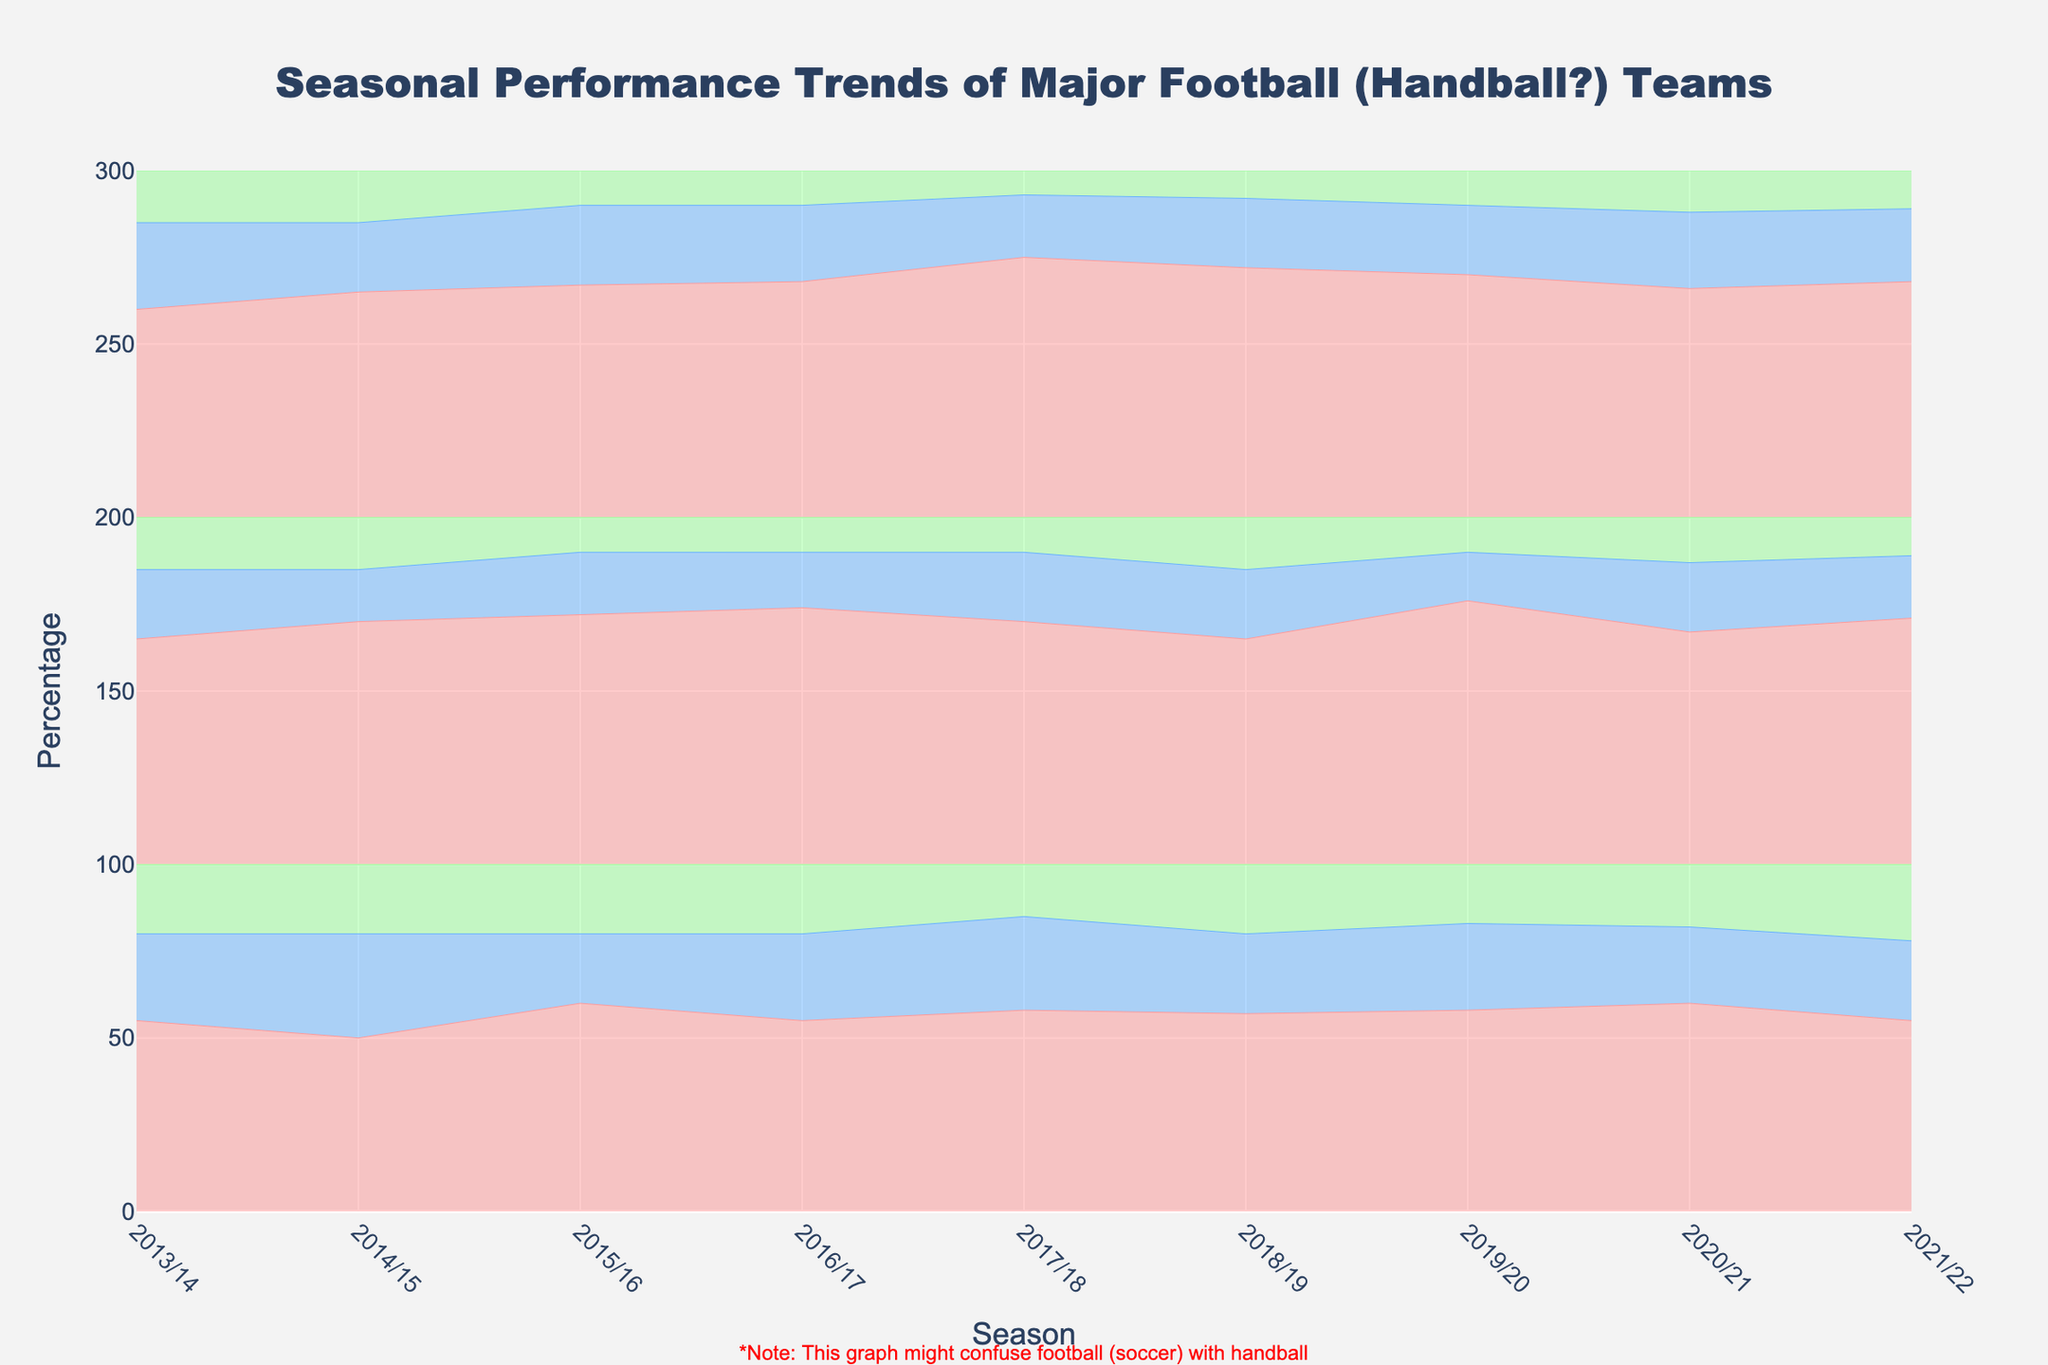what is the title of the graph? The title is displayed prominently at the top of the graph. It reads "Seasonal Performance Trends of Major Football (Handball?) Teams".
Answer: Seasonal Performance Trends of Major Football (Handball?) Teams Which team had the highest win percentage in the 2017/18 season? By looking at the line representative for wins in the 2017/18 season, we can see that Barcelona had the highest percentage among the teams.
Answer: Barcelona How did Real Madrid's win percentage trend from the 2015/16 season to the 2021/22 season? We will observe the trend line for Real Madrid's win percentage within the stated seasons. It starts around 72% in 2015/16 and fluctuates, ending up around 71% in 2021/22 with peaks in between.
Answer: Fluctuated but ended around 71% Which season did Manchester United have the lowest win percentage? We look at each season's win percentage for Manchester United and identify the season with the lowest value. The 2014/15 season has the lowest win percentage at 50%.
Answer: 2014/15 Comparing Barcelona's draw percentages, in which season was it the highest? By focusing on the draw percentage for Barcelona through the seasons, we find that the highest draw percentage was in the 2013/14 season at 25%.
Answer: 2013/14 What is the range of Manchester United's loss percentages shown in the graph? Viewing the loss percentage lines for Manchester United across all seasons, we find the minimum value is 15% (in 2017/18) and the maximum value is 22% (in 2021/22).
Answer: 15%-22% How did the overall performance of Barcelona change in the 2019/20 season compared to the previous season? Comparing the win, draw, and loss percentages of Barcelona between the 2018/19 season and the 2019/20 season, we see that the win percentage drops slightly, the draw percentage remains the same, and the loss percentage increases slightly.
Answer: Slight drop in wins, same draw, slight increase in losses What is the difference in the maximum win percentage between Real Madrid and Manchester United across all seasons? Comparing the highest win percentage for Real Madrid (76% in 2019/20) and Manchester United (60% in 2020/21), we calculate the difference, which is 16%.
Answer: 16% How do the draw percentages compare between the three teams in the 2020/21 season? For the 2020/21 season, we look at the draw percentages: Manchester United at 22%, Real Madrid at 20%, Barcelona at 22%. We note Manchester United and Barcelona are equal and slightly higher than Real Madrid.
Answer: Manchester United = Barcelona > Real Madrid Which team consistently had the smallest loss percentage across all the seasons? We compare the loss percentages for all teams across each season. Real Madrid consistently shows relatively lower loss percentages ranging a maximum of 15% across multiple seasons.
Answer: Real Madrid 